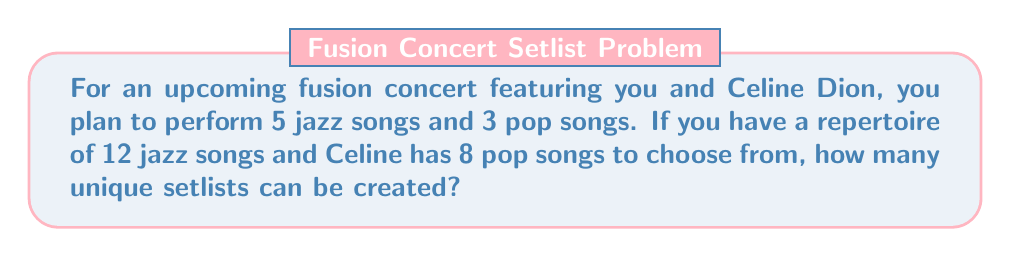Teach me how to tackle this problem. Let's approach this step-by-step:

1. For the jazz songs:
   - We need to choose 5 songs out of 12.
   - This is a combination problem, as the order doesn't matter.
   - We use the combination formula: $${12 \choose 5} = \frac{12!}{5!(12-5)!} = \frac{12!}{5!7!}$$

2. For the pop songs:
   - We need to choose 3 songs out of 8.
   - Again, this is a combination: $${8 \choose 3} = \frac{8!}{3!(8-3)!} = \frac{8!}{3!5!}$$

3. Calculate the jazz combinations:
   $${12 \choose 5} = \frac{12!}{5!7!} = 792$$

4. Calculate the pop combinations:
   $${8 \choose 3} = \frac{8!}{3!5!} = 56$$

5. Apply the multiplication principle:
   - For each way of choosing jazz songs, we can choose pop songs in all possible ways.
   - Total number of setlists = (Number of ways to choose jazz songs) × (Number of ways to choose pop songs)
   - Total = 792 × 56 = 44,352

Therefore, the number of unique setlists is 44,352.
Answer: 44,352 